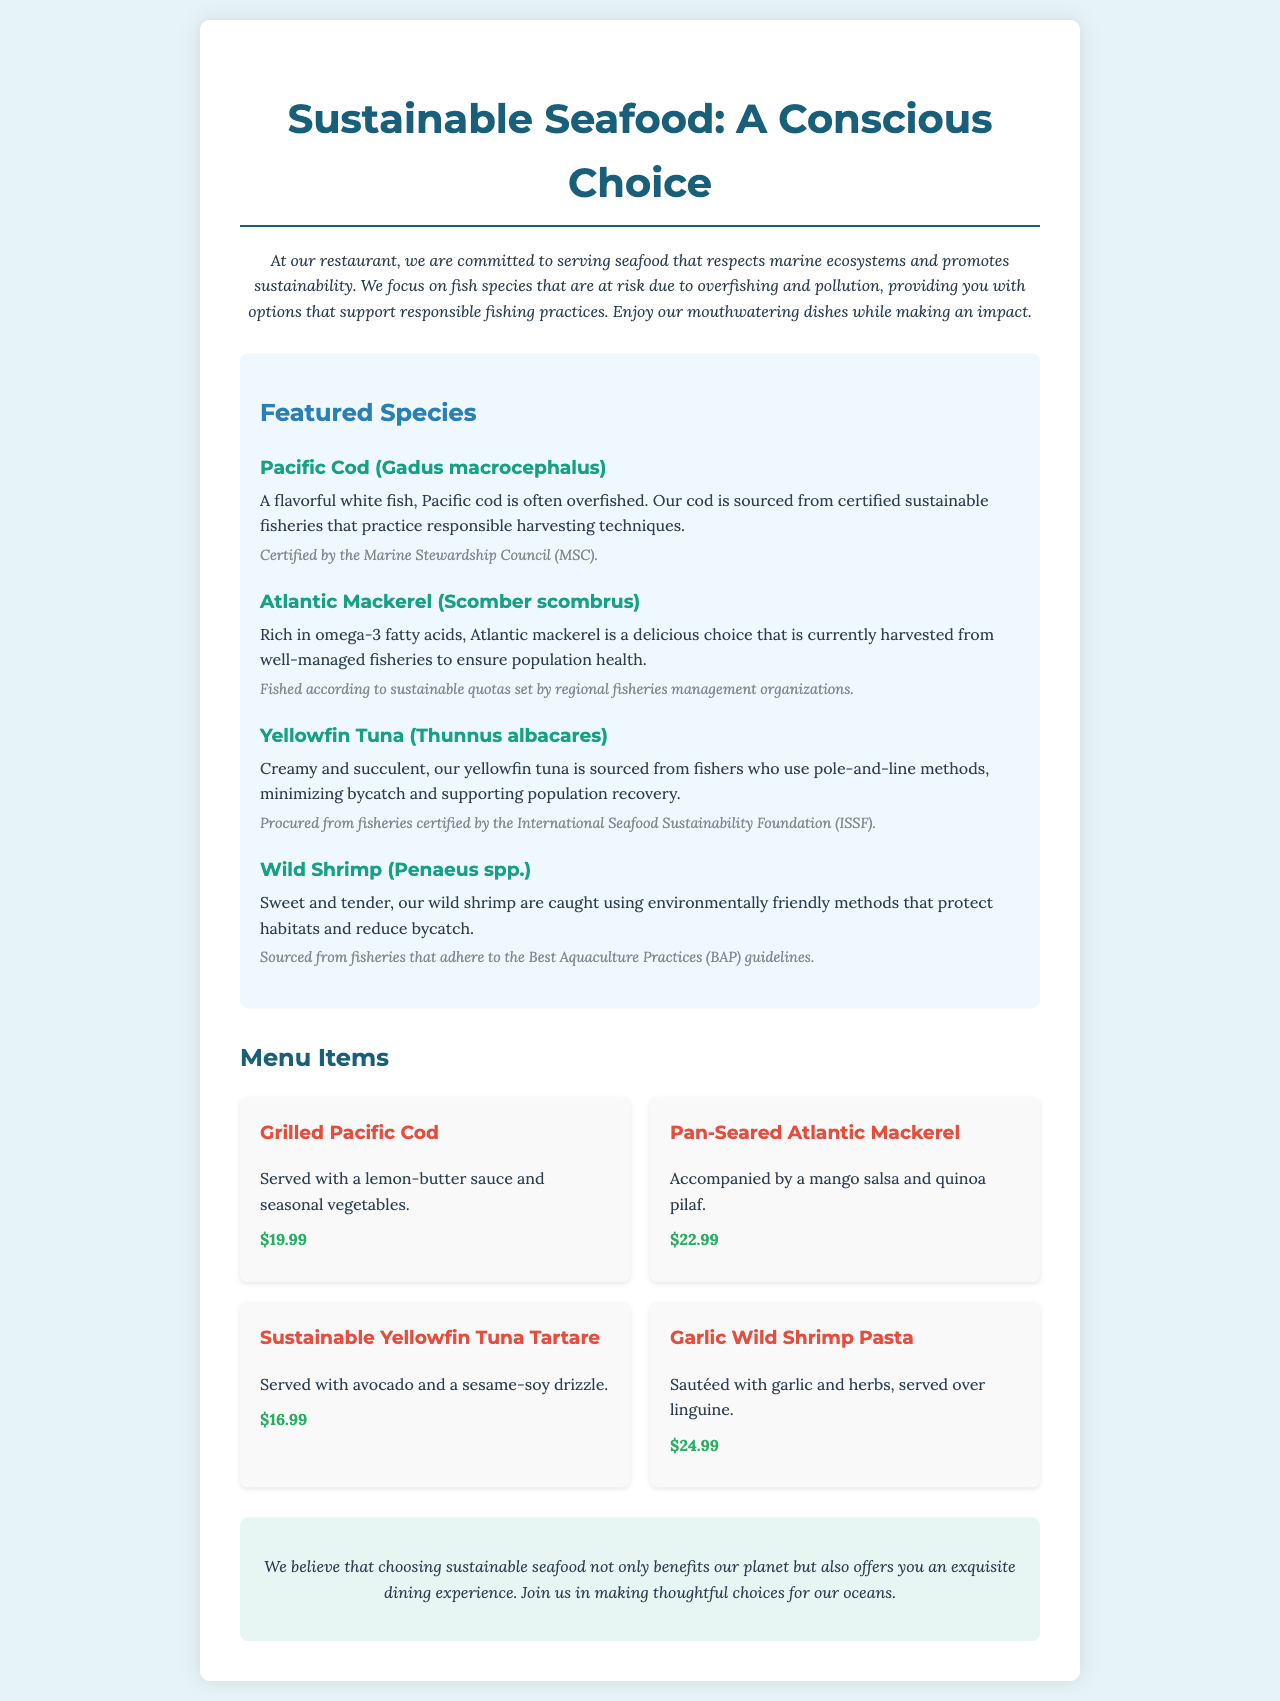What is the title of the menu? The title of the menu is the main heading that introduces the content of the document.
Answer: Sustainable Seafood: A Conscious Choice How much does the Grilled Pacific Cod cost? The cost of the Grilled Pacific Cod is listed under the menu items.
Answer: $19.99 What is the sourcing certification for Pacific Cod? This information is provided as a sourcing detail in the featured species section.
Answer: Certified by the Marine Stewardship Council (MSC) Which fish is rich in omega-3 fatty acids? This detail can be found in the description of one of the featured species.
Answer: Atlantic Mackerel How many menu items are listed in the document? The total number of menu items can be counted from the menu items section.
Answer: Four 